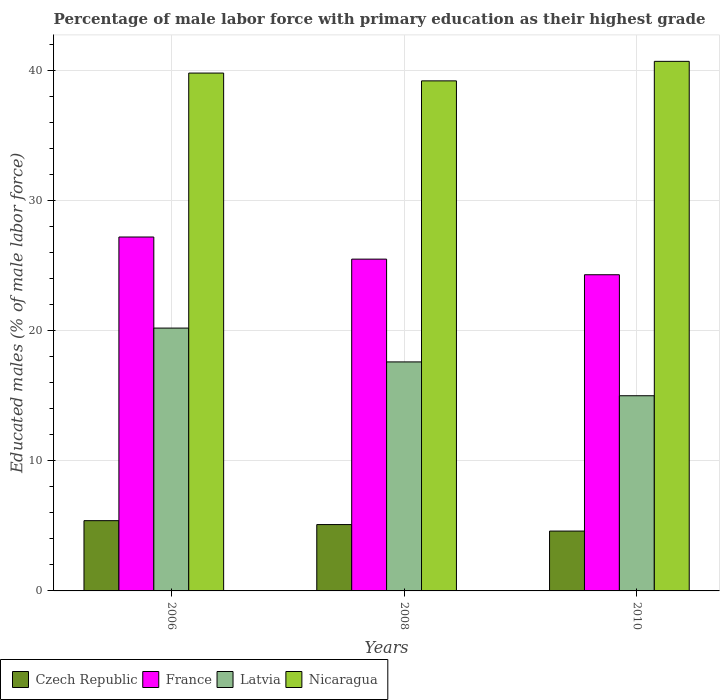How many different coloured bars are there?
Give a very brief answer. 4. How many groups of bars are there?
Offer a terse response. 3. How many bars are there on the 2nd tick from the left?
Provide a short and direct response. 4. In how many cases, is the number of bars for a given year not equal to the number of legend labels?
Provide a short and direct response. 0. What is the percentage of male labor force with primary education in Nicaragua in 2008?
Keep it short and to the point. 39.2. Across all years, what is the maximum percentage of male labor force with primary education in Latvia?
Offer a very short reply. 20.2. Across all years, what is the minimum percentage of male labor force with primary education in Nicaragua?
Your answer should be compact. 39.2. In which year was the percentage of male labor force with primary education in France minimum?
Give a very brief answer. 2010. What is the total percentage of male labor force with primary education in Czech Republic in the graph?
Your answer should be compact. 15.1. What is the difference between the percentage of male labor force with primary education in Czech Republic in 2008 and that in 2010?
Provide a succinct answer. 0.5. What is the difference between the percentage of male labor force with primary education in Nicaragua in 2008 and the percentage of male labor force with primary education in Czech Republic in 2010?
Your answer should be very brief. 34.6. What is the average percentage of male labor force with primary education in France per year?
Give a very brief answer. 25.67. In the year 2010, what is the difference between the percentage of male labor force with primary education in Czech Republic and percentage of male labor force with primary education in France?
Ensure brevity in your answer.  -19.7. What is the ratio of the percentage of male labor force with primary education in Czech Republic in 2006 to that in 2008?
Ensure brevity in your answer.  1.06. What is the difference between the highest and the second highest percentage of male labor force with primary education in Nicaragua?
Your response must be concise. 0.9. What is the difference between the highest and the lowest percentage of male labor force with primary education in Latvia?
Provide a short and direct response. 5.2. Is the sum of the percentage of male labor force with primary education in Latvia in 2006 and 2010 greater than the maximum percentage of male labor force with primary education in Nicaragua across all years?
Offer a very short reply. No. What does the 1st bar from the left in 2006 represents?
Provide a succinct answer. Czech Republic. What does the 4th bar from the right in 2006 represents?
Your answer should be compact. Czech Republic. Is it the case that in every year, the sum of the percentage of male labor force with primary education in Latvia and percentage of male labor force with primary education in Nicaragua is greater than the percentage of male labor force with primary education in Czech Republic?
Your answer should be very brief. Yes. Are the values on the major ticks of Y-axis written in scientific E-notation?
Your response must be concise. No. Does the graph contain any zero values?
Keep it short and to the point. No. Where does the legend appear in the graph?
Your response must be concise. Bottom left. How are the legend labels stacked?
Your answer should be very brief. Horizontal. What is the title of the graph?
Make the answer very short. Percentage of male labor force with primary education as their highest grade. Does "Thailand" appear as one of the legend labels in the graph?
Ensure brevity in your answer.  No. What is the label or title of the Y-axis?
Your response must be concise. Educated males (% of male labor force). What is the Educated males (% of male labor force) in Czech Republic in 2006?
Provide a short and direct response. 5.4. What is the Educated males (% of male labor force) in France in 2006?
Ensure brevity in your answer.  27.2. What is the Educated males (% of male labor force) of Latvia in 2006?
Offer a terse response. 20.2. What is the Educated males (% of male labor force) of Nicaragua in 2006?
Make the answer very short. 39.8. What is the Educated males (% of male labor force) in Czech Republic in 2008?
Your answer should be very brief. 5.1. What is the Educated males (% of male labor force) of France in 2008?
Make the answer very short. 25.5. What is the Educated males (% of male labor force) of Latvia in 2008?
Offer a terse response. 17.6. What is the Educated males (% of male labor force) in Nicaragua in 2008?
Make the answer very short. 39.2. What is the Educated males (% of male labor force) in Czech Republic in 2010?
Your answer should be very brief. 4.6. What is the Educated males (% of male labor force) in France in 2010?
Your answer should be very brief. 24.3. What is the Educated males (% of male labor force) of Nicaragua in 2010?
Give a very brief answer. 40.7. Across all years, what is the maximum Educated males (% of male labor force) of Czech Republic?
Make the answer very short. 5.4. Across all years, what is the maximum Educated males (% of male labor force) in France?
Offer a terse response. 27.2. Across all years, what is the maximum Educated males (% of male labor force) of Latvia?
Make the answer very short. 20.2. Across all years, what is the maximum Educated males (% of male labor force) in Nicaragua?
Keep it short and to the point. 40.7. Across all years, what is the minimum Educated males (% of male labor force) in Czech Republic?
Offer a terse response. 4.6. Across all years, what is the minimum Educated males (% of male labor force) in France?
Provide a succinct answer. 24.3. Across all years, what is the minimum Educated males (% of male labor force) in Latvia?
Your response must be concise. 15. Across all years, what is the minimum Educated males (% of male labor force) in Nicaragua?
Make the answer very short. 39.2. What is the total Educated males (% of male labor force) of Czech Republic in the graph?
Ensure brevity in your answer.  15.1. What is the total Educated males (% of male labor force) of Latvia in the graph?
Offer a terse response. 52.8. What is the total Educated males (% of male labor force) in Nicaragua in the graph?
Offer a very short reply. 119.7. What is the difference between the Educated males (% of male labor force) in France in 2006 and that in 2008?
Your answer should be very brief. 1.7. What is the difference between the Educated males (% of male labor force) of Latvia in 2006 and that in 2008?
Offer a terse response. 2.6. What is the difference between the Educated males (% of male labor force) of France in 2006 and that in 2010?
Your response must be concise. 2.9. What is the difference between the Educated males (% of male labor force) in Czech Republic in 2008 and that in 2010?
Your response must be concise. 0.5. What is the difference between the Educated males (% of male labor force) in France in 2008 and that in 2010?
Your answer should be very brief. 1.2. What is the difference between the Educated males (% of male labor force) in Latvia in 2008 and that in 2010?
Your answer should be compact. 2.6. What is the difference between the Educated males (% of male labor force) in Czech Republic in 2006 and the Educated males (% of male labor force) in France in 2008?
Ensure brevity in your answer.  -20.1. What is the difference between the Educated males (% of male labor force) of Czech Republic in 2006 and the Educated males (% of male labor force) of Nicaragua in 2008?
Give a very brief answer. -33.8. What is the difference between the Educated males (% of male labor force) of France in 2006 and the Educated males (% of male labor force) of Latvia in 2008?
Your answer should be very brief. 9.6. What is the difference between the Educated males (% of male labor force) of France in 2006 and the Educated males (% of male labor force) of Nicaragua in 2008?
Provide a short and direct response. -12. What is the difference between the Educated males (% of male labor force) of Latvia in 2006 and the Educated males (% of male labor force) of Nicaragua in 2008?
Your answer should be very brief. -19. What is the difference between the Educated males (% of male labor force) in Czech Republic in 2006 and the Educated males (% of male labor force) in France in 2010?
Give a very brief answer. -18.9. What is the difference between the Educated males (% of male labor force) in Czech Republic in 2006 and the Educated males (% of male labor force) in Nicaragua in 2010?
Keep it short and to the point. -35.3. What is the difference between the Educated males (% of male labor force) of France in 2006 and the Educated males (% of male labor force) of Latvia in 2010?
Your answer should be compact. 12.2. What is the difference between the Educated males (% of male labor force) in France in 2006 and the Educated males (% of male labor force) in Nicaragua in 2010?
Make the answer very short. -13.5. What is the difference between the Educated males (% of male labor force) in Latvia in 2006 and the Educated males (% of male labor force) in Nicaragua in 2010?
Ensure brevity in your answer.  -20.5. What is the difference between the Educated males (% of male labor force) of Czech Republic in 2008 and the Educated males (% of male labor force) of France in 2010?
Provide a short and direct response. -19.2. What is the difference between the Educated males (% of male labor force) in Czech Republic in 2008 and the Educated males (% of male labor force) in Latvia in 2010?
Provide a short and direct response. -9.9. What is the difference between the Educated males (% of male labor force) of Czech Republic in 2008 and the Educated males (% of male labor force) of Nicaragua in 2010?
Keep it short and to the point. -35.6. What is the difference between the Educated males (% of male labor force) in France in 2008 and the Educated males (% of male labor force) in Nicaragua in 2010?
Make the answer very short. -15.2. What is the difference between the Educated males (% of male labor force) of Latvia in 2008 and the Educated males (% of male labor force) of Nicaragua in 2010?
Your response must be concise. -23.1. What is the average Educated males (% of male labor force) in Czech Republic per year?
Offer a very short reply. 5.03. What is the average Educated males (% of male labor force) in France per year?
Provide a succinct answer. 25.67. What is the average Educated males (% of male labor force) of Latvia per year?
Your answer should be compact. 17.6. What is the average Educated males (% of male labor force) in Nicaragua per year?
Offer a terse response. 39.9. In the year 2006, what is the difference between the Educated males (% of male labor force) in Czech Republic and Educated males (% of male labor force) in France?
Keep it short and to the point. -21.8. In the year 2006, what is the difference between the Educated males (% of male labor force) in Czech Republic and Educated males (% of male labor force) in Latvia?
Your answer should be very brief. -14.8. In the year 2006, what is the difference between the Educated males (% of male labor force) of Czech Republic and Educated males (% of male labor force) of Nicaragua?
Keep it short and to the point. -34.4. In the year 2006, what is the difference between the Educated males (% of male labor force) in France and Educated males (% of male labor force) in Latvia?
Provide a succinct answer. 7. In the year 2006, what is the difference between the Educated males (% of male labor force) of Latvia and Educated males (% of male labor force) of Nicaragua?
Keep it short and to the point. -19.6. In the year 2008, what is the difference between the Educated males (% of male labor force) of Czech Republic and Educated males (% of male labor force) of France?
Offer a terse response. -20.4. In the year 2008, what is the difference between the Educated males (% of male labor force) in Czech Republic and Educated males (% of male labor force) in Nicaragua?
Offer a very short reply. -34.1. In the year 2008, what is the difference between the Educated males (% of male labor force) of France and Educated males (% of male labor force) of Nicaragua?
Ensure brevity in your answer.  -13.7. In the year 2008, what is the difference between the Educated males (% of male labor force) of Latvia and Educated males (% of male labor force) of Nicaragua?
Offer a very short reply. -21.6. In the year 2010, what is the difference between the Educated males (% of male labor force) in Czech Republic and Educated males (% of male labor force) in France?
Provide a short and direct response. -19.7. In the year 2010, what is the difference between the Educated males (% of male labor force) of Czech Republic and Educated males (% of male labor force) of Latvia?
Make the answer very short. -10.4. In the year 2010, what is the difference between the Educated males (% of male labor force) of Czech Republic and Educated males (% of male labor force) of Nicaragua?
Make the answer very short. -36.1. In the year 2010, what is the difference between the Educated males (% of male labor force) of France and Educated males (% of male labor force) of Nicaragua?
Offer a very short reply. -16.4. In the year 2010, what is the difference between the Educated males (% of male labor force) of Latvia and Educated males (% of male labor force) of Nicaragua?
Your answer should be very brief. -25.7. What is the ratio of the Educated males (% of male labor force) of Czech Republic in 2006 to that in 2008?
Offer a very short reply. 1.06. What is the ratio of the Educated males (% of male labor force) of France in 2006 to that in 2008?
Provide a succinct answer. 1.07. What is the ratio of the Educated males (% of male labor force) in Latvia in 2006 to that in 2008?
Provide a succinct answer. 1.15. What is the ratio of the Educated males (% of male labor force) of Nicaragua in 2006 to that in 2008?
Offer a very short reply. 1.02. What is the ratio of the Educated males (% of male labor force) of Czech Republic in 2006 to that in 2010?
Make the answer very short. 1.17. What is the ratio of the Educated males (% of male labor force) of France in 2006 to that in 2010?
Make the answer very short. 1.12. What is the ratio of the Educated males (% of male labor force) of Latvia in 2006 to that in 2010?
Offer a very short reply. 1.35. What is the ratio of the Educated males (% of male labor force) in Nicaragua in 2006 to that in 2010?
Offer a very short reply. 0.98. What is the ratio of the Educated males (% of male labor force) in Czech Republic in 2008 to that in 2010?
Your answer should be compact. 1.11. What is the ratio of the Educated males (% of male labor force) in France in 2008 to that in 2010?
Provide a succinct answer. 1.05. What is the ratio of the Educated males (% of male labor force) in Latvia in 2008 to that in 2010?
Give a very brief answer. 1.17. What is the ratio of the Educated males (% of male labor force) in Nicaragua in 2008 to that in 2010?
Your answer should be very brief. 0.96. What is the difference between the highest and the second highest Educated males (% of male labor force) of Czech Republic?
Make the answer very short. 0.3. What is the difference between the highest and the second highest Educated males (% of male labor force) of France?
Provide a succinct answer. 1.7. What is the difference between the highest and the second highest Educated males (% of male labor force) in Latvia?
Your answer should be very brief. 2.6. What is the difference between the highest and the second highest Educated males (% of male labor force) in Nicaragua?
Provide a short and direct response. 0.9. 